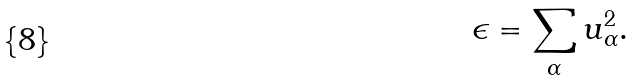<formula> <loc_0><loc_0><loc_500><loc_500>\epsilon = \sum _ { \alpha } { u } _ { \alpha } ^ { 2 } .</formula> 